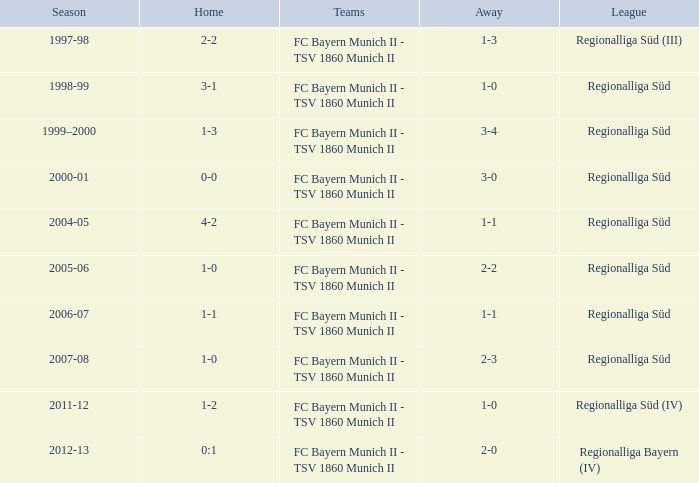What is the home with a 1-1 away in the 2004-05 season? 4-2. 